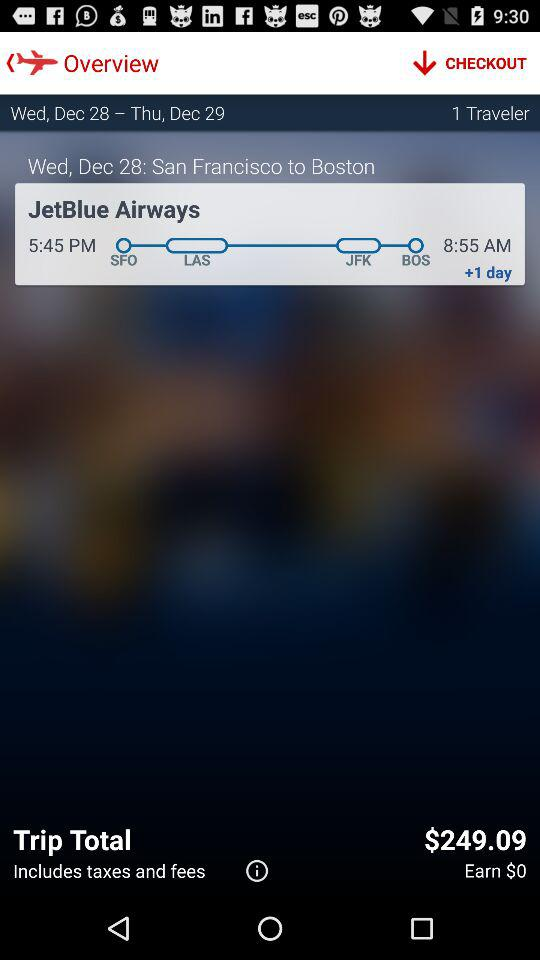How much is the total trip price? The total trip price is $249.09. 